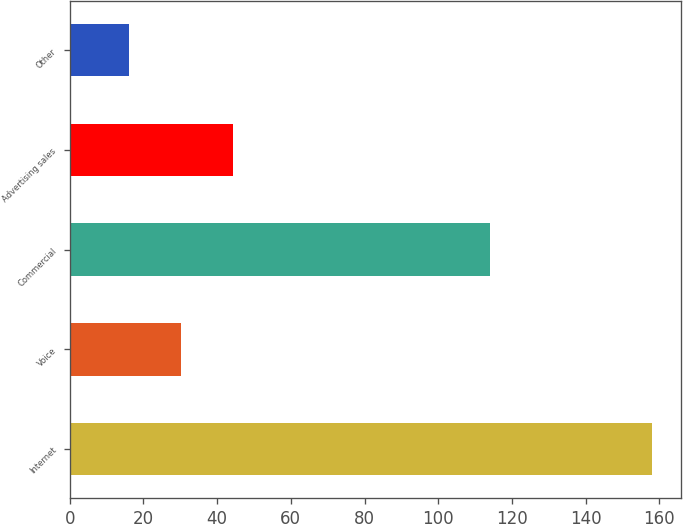Convert chart to OTSL. <chart><loc_0><loc_0><loc_500><loc_500><bar_chart><fcel>Internet<fcel>Voice<fcel>Commercial<fcel>Advertising sales<fcel>Other<nl><fcel>158<fcel>30.2<fcel>114<fcel>44.4<fcel>16<nl></chart> 